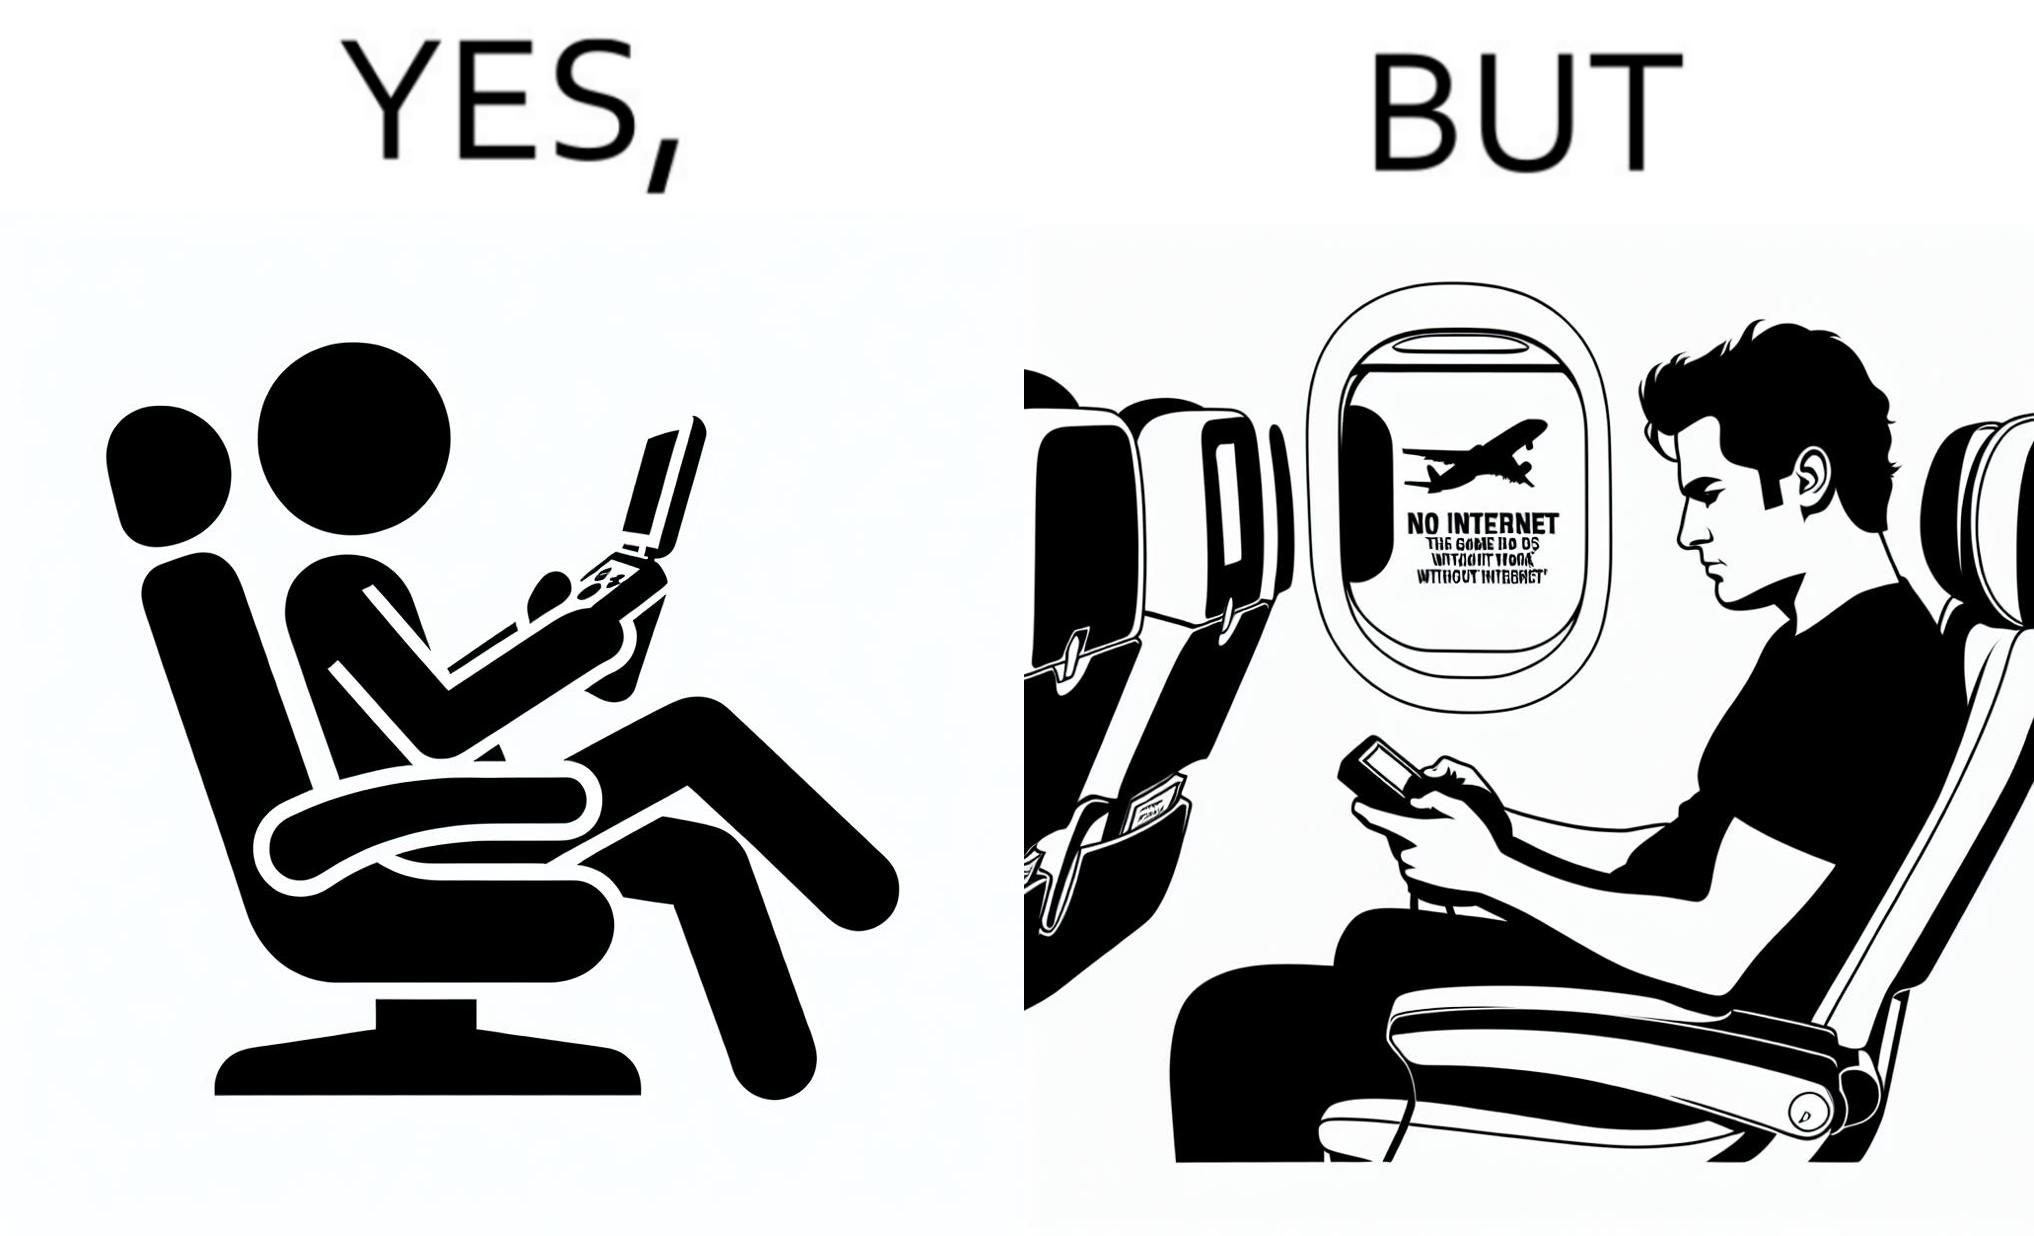Provide a description of this image. The image is ironic, as the person is holding the game console to play a game during the flight. However, the person is unable to play the game, as the game requires internet (as is the case with many modern games), and internet is unavailable in many lights. 